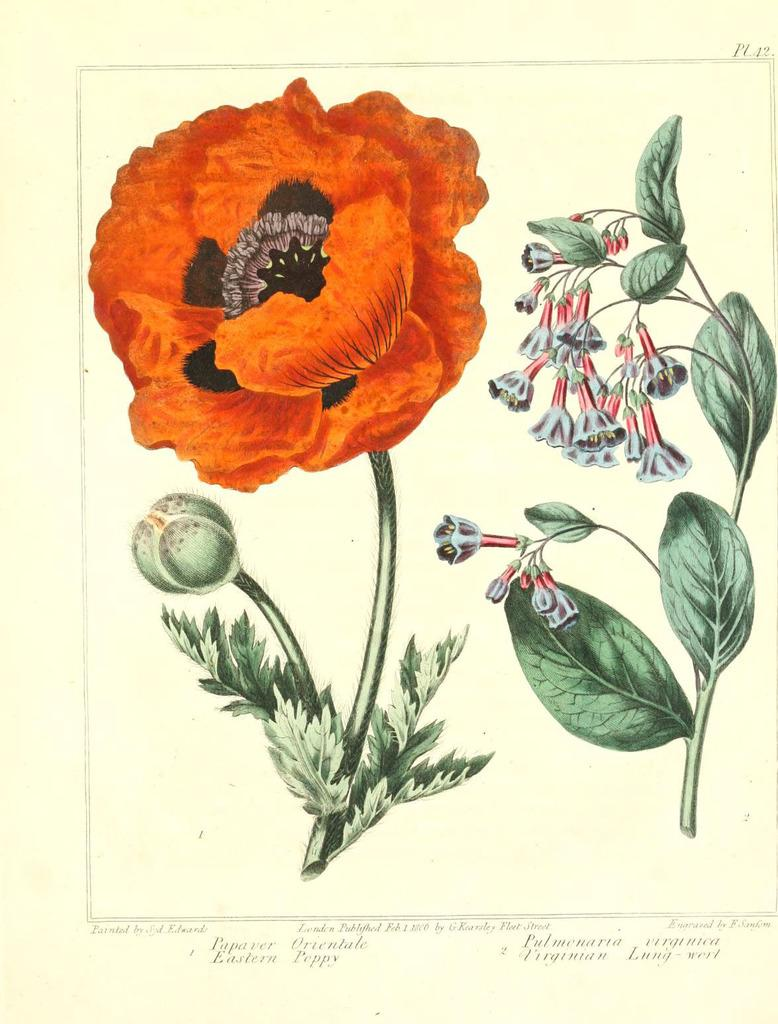What type of plants are depicted in the image? The image contains a picture of flowers and leaves. Can you describe the text at the bottom of the image? Unfortunately, the provided facts do not give any information about the text at the bottom of the image. What is the primary focus of the image? The primary focus of the image is the picture of flowers and leaves. What type of lumber is being used for the voyage in the image? There is no mention of lumber or a voyage in the image; it contains a picture of flowers and leaves with text at the bottom. 